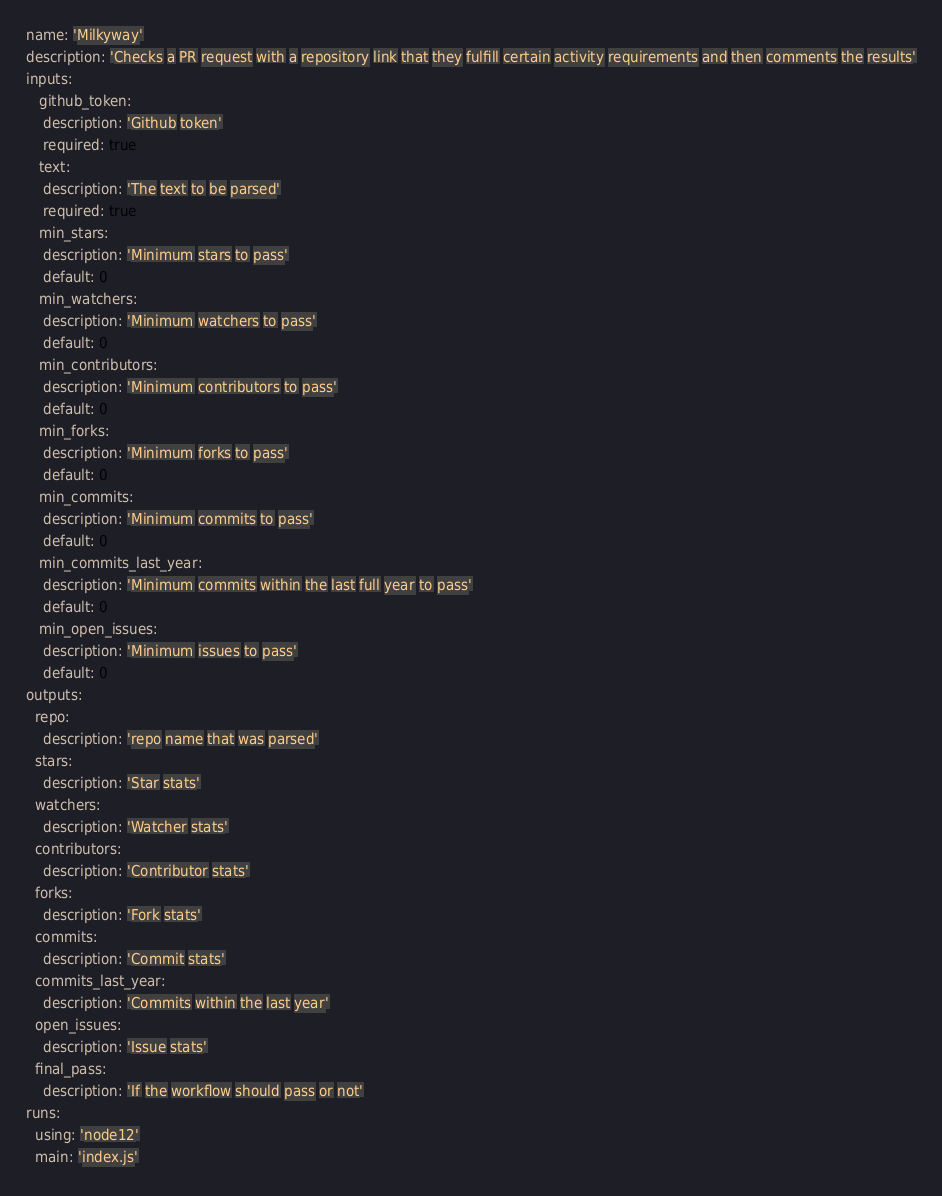Convert code to text. <code><loc_0><loc_0><loc_500><loc_500><_YAML_>name: 'Milkyway'
description: 'Checks a PR request with a repository link that they fulfill certain activity requirements and then comments the results'
inputs:
   github_token:
    description: 'Github token'
    required: true
   text:
    description: 'The text to be parsed'
    required: true
   min_stars:
    description: 'Minimum stars to pass'
    default: 0
   min_watchers:
    description: 'Minimum watchers to pass'
    default: 0
   min_contributors:
    description: 'Minimum contributors to pass'
    default: 0
   min_forks:
    description: 'Minimum forks to pass'
    default: 0
   min_commits:
    description: 'Minimum commits to pass'
    default: 0
   min_commits_last_year:
    description: 'Minimum commits within the last full year to pass'
    default: 0
   min_open_issues:
    description: 'Minimum issues to pass'
    default: 0
outputs:
  repo:
    description: 'repo name that was parsed'
  stars:
    description: 'Star stats'
  watchers:
    description: 'Watcher stats'
  contributors:
    description: 'Contributor stats'
  forks:
    description: 'Fork stats'
  commits:
    description: 'Commit stats'
  commits_last_year:
    description: 'Commits within the last year'
  open_issues:
    description: 'Issue stats'
  final_pass:
    description: 'If the workflow should pass or not'
runs:
  using: 'node12'
  main: 'index.js'
</code> 